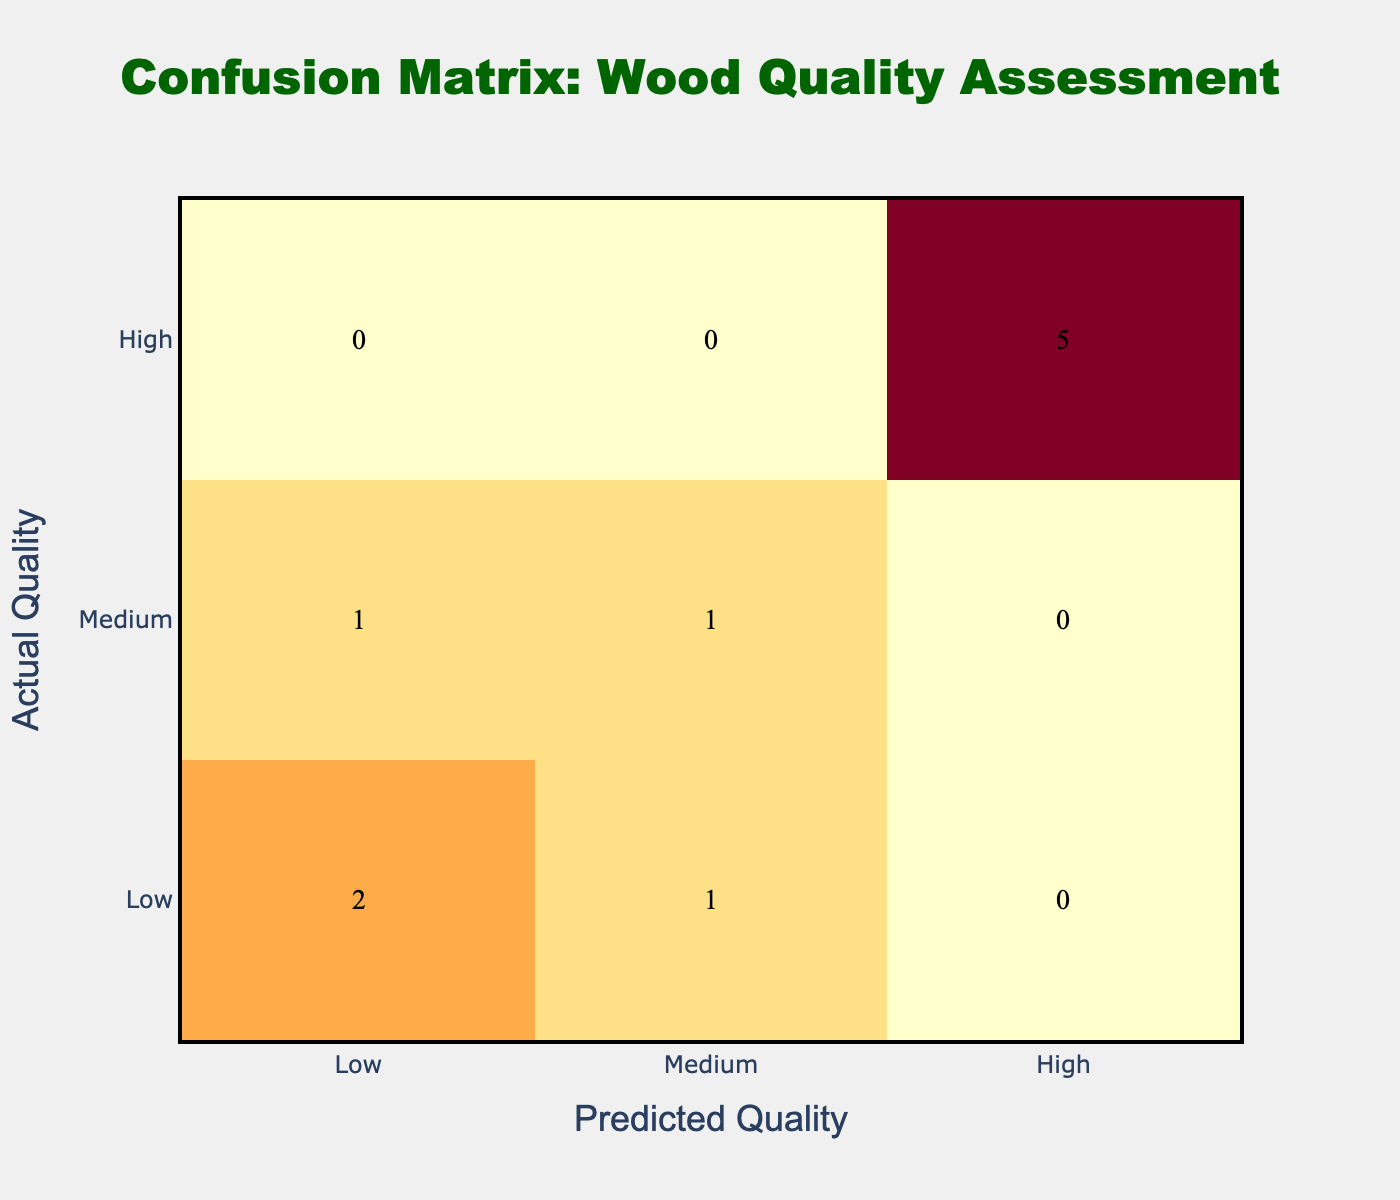What is the total number of 'High' quality predictions? Looking at the 'High' column in the confusion matrix, the values are 3 for 'Actual High', 0 for 'Actual Medium', and 2 for 'Actual Low'. Summing these values gives 3 + 0 + 2 = 5.
Answer: 5 What percentage of customers rated the wood as 'Medium Quality'? There are 10 customers in total. The count of customers giving feedback as 'Medium Quality' is 2. To find the percentage, divide 2 by 10 and multiply by 100, giving (2/10) * 100 = 20%.
Answer: 20% Is it true that all of the customers who rated the wood as 'Very Low Quality' also considered it as 'Low' quality? The confusion matrix shows that all predictions for 'Very Low Quality' are categorized under 'Low', hence there are no instances of 'Very Low Quality' being predicted as 'Medium' or 'High'. Therefore, this statement is true.
Answer: Yes What is the difference between the number of 'Low' quality assessments and 'Medium' quality assessments? In the matrix, the 'Low' Quality assessments are 3 (2 from 'Actual Low' and 1 from 'Actual Medium'), and the 'Medium' Quality assessments are 3 (from 'Actual Medium'). The difference is 3 (Low) - 3 (Medium) = 0.
Answer: 0 How many customers correctly identified the wood quality when it was 'High'? The confusion matrix indicates that there are 3 customers who predicted 'High' quality while the actual quality was indeed 'High'. Therefore, the correct identification count is 3.
Answer: 3 Was there any customer feedback indicating 'Poor Quality' that was assessed as 'Low'? In the confusion matrix, the 'Poor Quality' feedback uniquely maps to only 'Low', indicating that all instances assessed as 'Poor Quality' were indeed classified as 'Low'. Thus, the statement is valid.
Answer: Yes How many customers provided feedback with a quality assessment of either 'Low' or 'Medium'? From the confusion matrix, the 'Low' quality count is 3 (1 from 'Actual Low' and 2 from 'Actual Medium') and the 'Medium' quality count is 3 (all 'Actual Medium'). Thus, the combined count is 3 + 3 = 6.
Answer: 6 Which actual quality assessment had the least correct predictions? The confusion matrix shows that 'Low' quality had the least correct predictions with 1 customer that correctly identified it while 'High' had more. Thus, 'Low' quality is the answer.
Answer: Low 